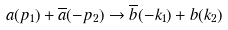<formula> <loc_0><loc_0><loc_500><loc_500>a ( p _ { 1 } ) + \overline { a } ( - p _ { 2 } ) \to \overline { b } ( - k _ { 1 } ) + b ( k _ { 2 } )</formula> 